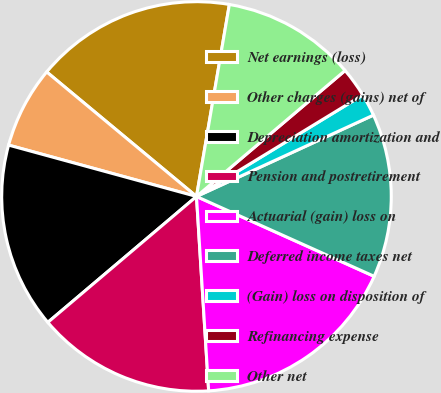<chart> <loc_0><loc_0><loc_500><loc_500><pie_chart><fcel>Net earnings (loss)<fcel>Other charges (gains) net of<fcel>Depreciation amortization and<fcel>Pension and postretirement<fcel>Actuarial (gain) loss on<fcel>Deferred income taxes net<fcel>(Gain) loss on disposition of<fcel>Refinancing expense<fcel>Other net<nl><fcel>16.66%<fcel>6.79%<fcel>15.43%<fcel>14.81%<fcel>17.28%<fcel>13.58%<fcel>1.86%<fcel>2.47%<fcel>11.11%<nl></chart> 